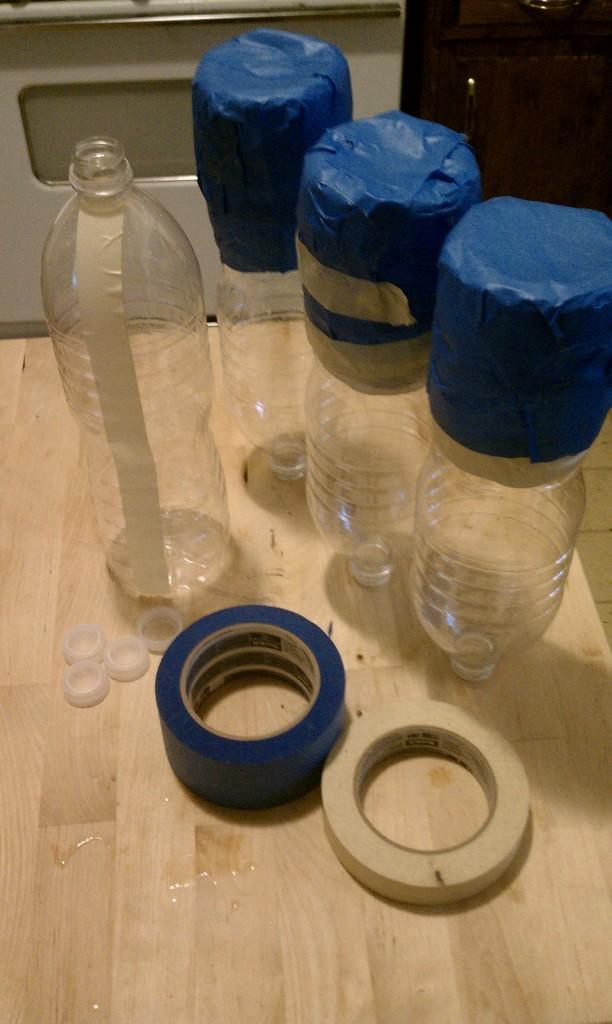In one or two sentences, can you explain what this image depicts? This image is taken inside a room. In this image there is a wooden table on which there are few empty bottles and two plasters and a door. 